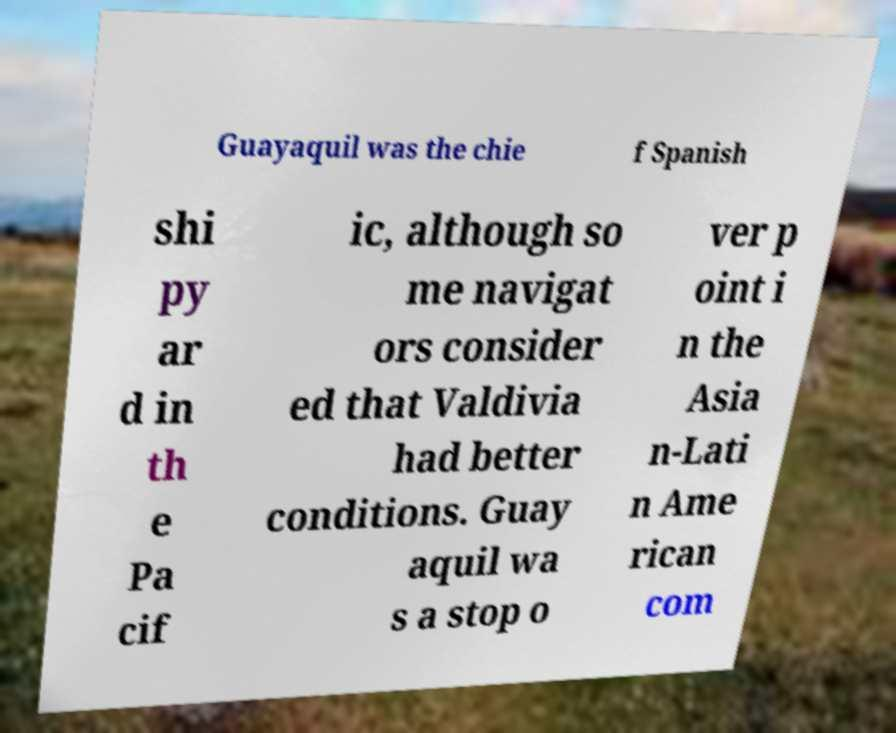For documentation purposes, I need the text within this image transcribed. Could you provide that? Guayaquil was the chie f Spanish shi py ar d in th e Pa cif ic, although so me navigat ors consider ed that Valdivia had better conditions. Guay aquil wa s a stop o ver p oint i n the Asia n-Lati n Ame rican com 